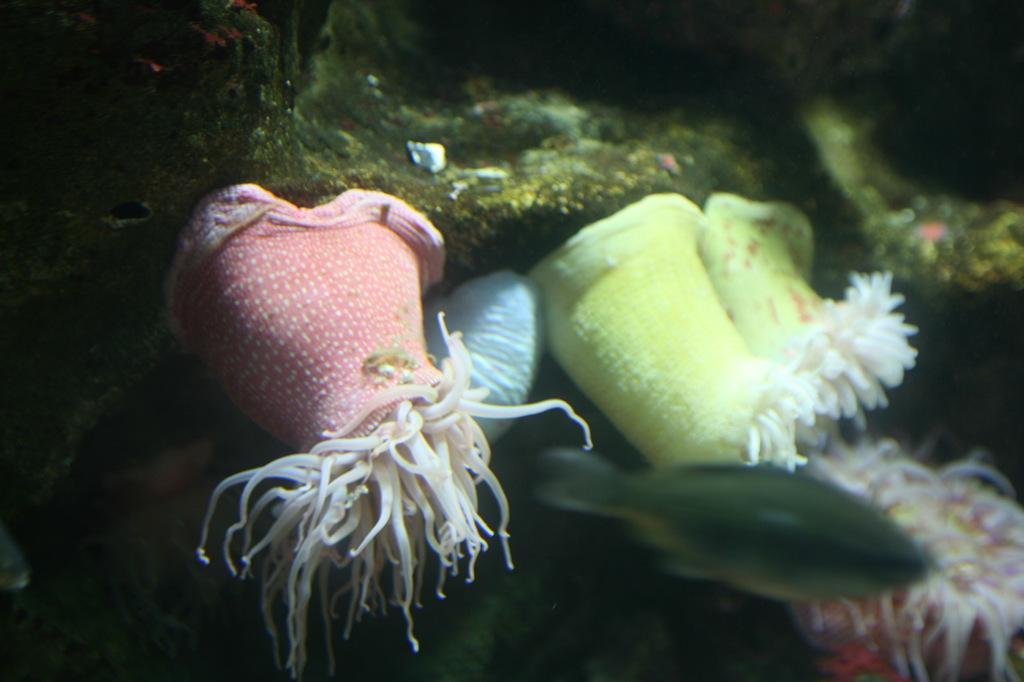What colors are the objects in the image? The objects in the image are in light green, blue, and pink colors. Where are these objects located? These objects are in water. Is there any living creature present in the image? Yes, there is a fish beside the objects in the image. How many cribs can be seen in the image? There are no cribs present in the image. What type of chairs are visible in the image? There are no chairs visible in the image. 